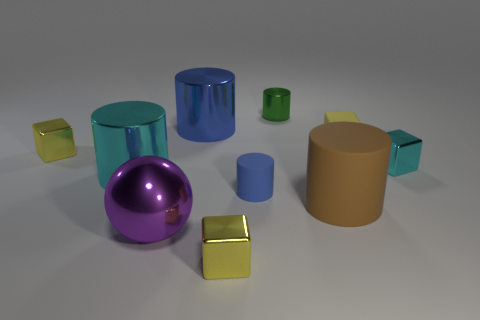Does the tiny rubber cube have the same color as the small thing that is left of the ball?
Make the answer very short. Yes. Are there any small shiny blocks that have the same color as the matte cube?
Ensure brevity in your answer.  Yes. There is a big thing that is the same color as the tiny rubber cylinder; what shape is it?
Offer a terse response. Cylinder. How many objects are blue cylinders in front of the small cyan object or large objects in front of the small blue matte object?
Your answer should be compact. 3. How many objects are yellow shiny cubes or cyan cubes?
Provide a short and direct response. 3. There is a yellow cube that is both right of the blue metallic cylinder and behind the large brown cylinder; what is its size?
Provide a short and direct response. Small. How many other big spheres are made of the same material as the sphere?
Your answer should be very brief. 0. What is the color of the large ball that is the same material as the tiny cyan block?
Your answer should be very brief. Purple. There is a small cylinder that is in front of the green metal cylinder; does it have the same color as the tiny rubber block?
Provide a succinct answer. No. There is a tiny thing behind the big blue metal thing; what material is it?
Offer a very short reply. Metal. 